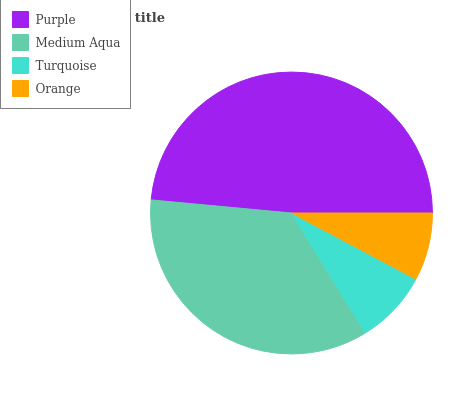Is Orange the minimum?
Answer yes or no. Yes. Is Purple the maximum?
Answer yes or no. Yes. Is Medium Aqua the minimum?
Answer yes or no. No. Is Medium Aqua the maximum?
Answer yes or no. No. Is Purple greater than Medium Aqua?
Answer yes or no. Yes. Is Medium Aqua less than Purple?
Answer yes or no. Yes. Is Medium Aqua greater than Purple?
Answer yes or no. No. Is Purple less than Medium Aqua?
Answer yes or no. No. Is Medium Aqua the high median?
Answer yes or no. Yes. Is Turquoise the low median?
Answer yes or no. Yes. Is Turquoise the high median?
Answer yes or no. No. Is Purple the low median?
Answer yes or no. No. 